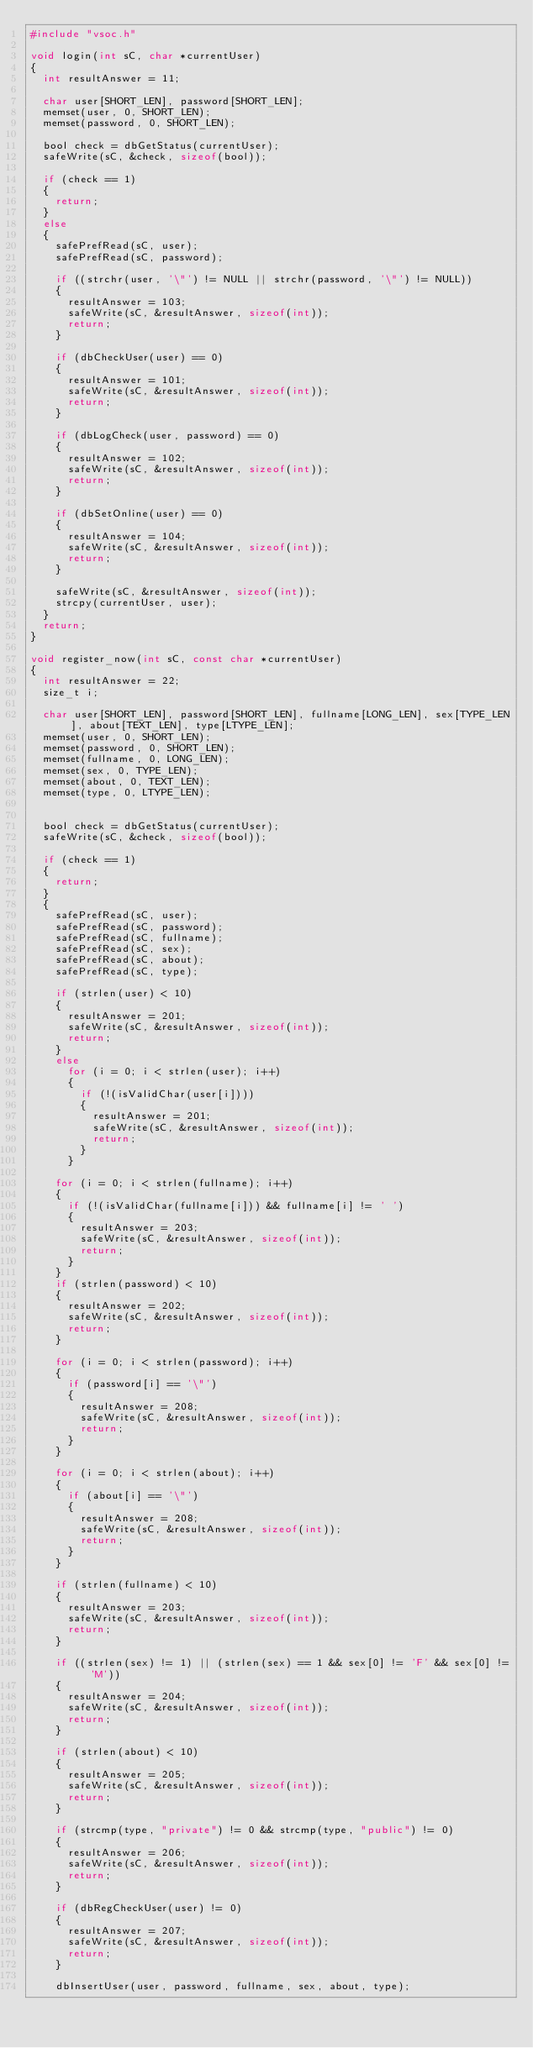<code> <loc_0><loc_0><loc_500><loc_500><_C_>#include "vsoc.h"

void login(int sC, char *currentUser)
{
	int resultAnswer = 11;

	char user[SHORT_LEN], password[SHORT_LEN];
	memset(user, 0, SHORT_LEN);
	memset(password, 0, SHORT_LEN);

	bool check = dbGetStatus(currentUser);
	safeWrite(sC, &check, sizeof(bool));

	if (check == 1)
	{
		return;
	}
	else
	{
		safePrefRead(sC, user);
		safePrefRead(sC, password);

		if ((strchr(user, '\"') != NULL || strchr(password, '\"') != NULL))
		{
			resultAnswer = 103;
			safeWrite(sC, &resultAnswer, sizeof(int));
			return;
		}

		if (dbCheckUser(user) == 0)
		{
			resultAnswer = 101;
			safeWrite(sC, &resultAnswer, sizeof(int));
			return;
		}

		if (dbLogCheck(user, password) == 0)
		{
			resultAnswer = 102;
			safeWrite(sC, &resultAnswer, sizeof(int));
			return;
		}

		if (dbSetOnline(user) == 0)
		{
			resultAnswer = 104;
			safeWrite(sC, &resultAnswer, sizeof(int));
			return;
		}

		safeWrite(sC, &resultAnswer, sizeof(int));
		strcpy(currentUser, user);
	}
	return;
}

void register_now(int sC, const char *currentUser)
{
	int resultAnswer = 22;
	size_t i;

	char user[SHORT_LEN], password[SHORT_LEN], fullname[LONG_LEN], sex[TYPE_LEN], about[TEXT_LEN], type[LTYPE_LEN];
	memset(user, 0, SHORT_LEN);
	memset(password, 0, SHORT_LEN);
	memset(fullname, 0, LONG_LEN);
	memset(sex, 0, TYPE_LEN);
	memset(about, 0, TEXT_LEN);
	memset(type, 0, LTYPE_LEN);


	bool check = dbGetStatus(currentUser);
	safeWrite(sC, &check, sizeof(bool));

	if (check == 1)
	{
		return;
	}
	{
		safePrefRead(sC, user);
		safePrefRead(sC, password);
		safePrefRead(sC, fullname);
		safePrefRead(sC, sex);
		safePrefRead(sC, about);
		safePrefRead(sC, type);

		if (strlen(user) < 10)
		{
			resultAnswer = 201;
			safeWrite(sC, &resultAnswer, sizeof(int));
			return;
		}
		else
			for (i = 0; i < strlen(user); i++)
			{
				if (!(isValidChar(user[i])))
				{
					resultAnswer = 201;
					safeWrite(sC, &resultAnswer, sizeof(int));
					return;
				}
			}

		for (i = 0; i < strlen(fullname); i++)
		{
			if (!(isValidChar(fullname[i])) && fullname[i] != ' ')
			{
				resultAnswer = 203;
				safeWrite(sC, &resultAnswer, sizeof(int));
				return;
			}
		}
		if (strlen(password) < 10)
		{
			resultAnswer = 202;
			safeWrite(sC, &resultAnswer, sizeof(int));
			return;
		}

		for (i = 0; i < strlen(password); i++)
		{
			if (password[i] == '\"')
			{
				resultAnswer = 208;
				safeWrite(sC, &resultAnswer, sizeof(int));
				return;
			}
		}

		for (i = 0; i < strlen(about); i++)
		{
			if (about[i] == '\"')
			{
				resultAnswer = 208;
				safeWrite(sC, &resultAnswer, sizeof(int));
				return;
			}
		}

		if (strlen(fullname) < 10)
		{
			resultAnswer = 203;
			safeWrite(sC, &resultAnswer, sizeof(int));
			return;
		}

		if ((strlen(sex) != 1) || (strlen(sex) == 1 && sex[0] != 'F' && sex[0] != 'M'))
		{
			resultAnswer = 204;
			safeWrite(sC, &resultAnswer, sizeof(int));
			return;
		}

		if (strlen(about) < 10)
		{
			resultAnswer = 205;
			safeWrite(sC, &resultAnswer, sizeof(int));
			return;
		}

		if (strcmp(type, "private") != 0 && strcmp(type, "public") != 0)
		{
			resultAnswer = 206;
			safeWrite(sC, &resultAnswer, sizeof(int));
			return;
		}

		if (dbRegCheckUser(user) != 0)
		{
			resultAnswer = 207;
			safeWrite(sC, &resultAnswer, sizeof(int));
			return;
		}

		dbInsertUser(user, password, fullname, sex, about, type);</code> 